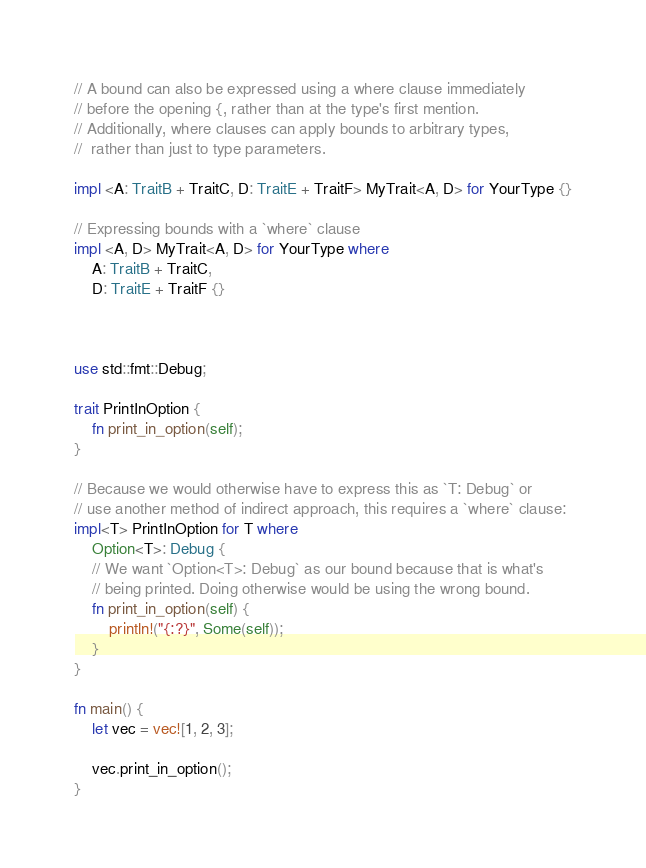Convert code to text. <code><loc_0><loc_0><loc_500><loc_500><_Rust_>// A bound can also be expressed using a where clause immediately 
// before the opening {, rather than at the type's first mention. 
// Additionally, where clauses can apply bounds to arbitrary types,
//  rather than just to type parameters.

impl <A: TraitB + TraitC, D: TraitE + TraitF> MyTrait<A, D> for YourType {}

// Expressing bounds with a `where` clause
impl <A, D> MyTrait<A, D> for YourType where
    A: TraitB + TraitC,
    D: TraitE + TraitF {}



use std::fmt::Debug;

trait PrintInOption {
    fn print_in_option(self);
}

// Because we would otherwise have to express this as `T: Debug` or 
// use another method of indirect approach, this requires a `where` clause:
impl<T> PrintInOption for T where
    Option<T>: Debug {
    // We want `Option<T>: Debug` as our bound because that is what's
    // being printed. Doing otherwise would be using the wrong bound.
    fn print_in_option(self) {
        println!("{:?}", Some(self));
    }
}

fn main() {
    let vec = vec![1, 2, 3];

    vec.print_in_option();
}    </code> 